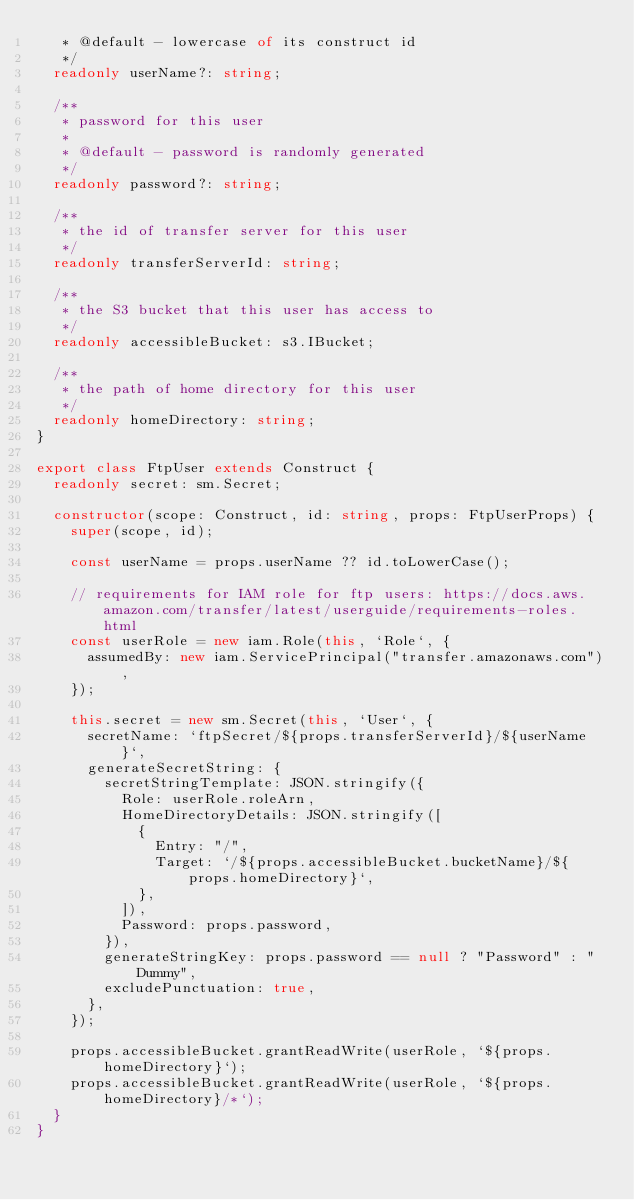Convert code to text. <code><loc_0><loc_0><loc_500><loc_500><_TypeScript_>   * @default - lowercase of its construct id
   */
  readonly userName?: string;

  /**
   * password for this user
   *
   * @default - password is randomly generated
   */
  readonly password?: string;

  /**
   * the id of transfer server for this user
   */
  readonly transferServerId: string;

  /**
   * the S3 bucket that this user has access to
   */
  readonly accessibleBucket: s3.IBucket;

  /**
   * the path of home directory for this user
   */
  readonly homeDirectory: string;
}

export class FtpUser extends Construct {
  readonly secret: sm.Secret;

  constructor(scope: Construct, id: string, props: FtpUserProps) {
    super(scope, id);

    const userName = props.userName ?? id.toLowerCase();

    // requirements for IAM role for ftp users: https://docs.aws.amazon.com/transfer/latest/userguide/requirements-roles.html
    const userRole = new iam.Role(this, `Role`, {
      assumedBy: new iam.ServicePrincipal("transfer.amazonaws.com"),
    });

    this.secret = new sm.Secret(this, `User`, {
      secretName: `ftpSecret/${props.transferServerId}/${userName}`,
      generateSecretString: {
        secretStringTemplate: JSON.stringify({
          Role: userRole.roleArn,
          HomeDirectoryDetails: JSON.stringify([
            {
              Entry: "/",
              Target: `/${props.accessibleBucket.bucketName}/${props.homeDirectory}`,
            },
          ]),
          Password: props.password,
        }),
        generateStringKey: props.password == null ? "Password" : "Dummy",
        excludePunctuation: true,
      },
    });

    props.accessibleBucket.grantReadWrite(userRole, `${props.homeDirectory}`);
    props.accessibleBucket.grantReadWrite(userRole, `${props.homeDirectory}/*`);
  }
}
</code> 